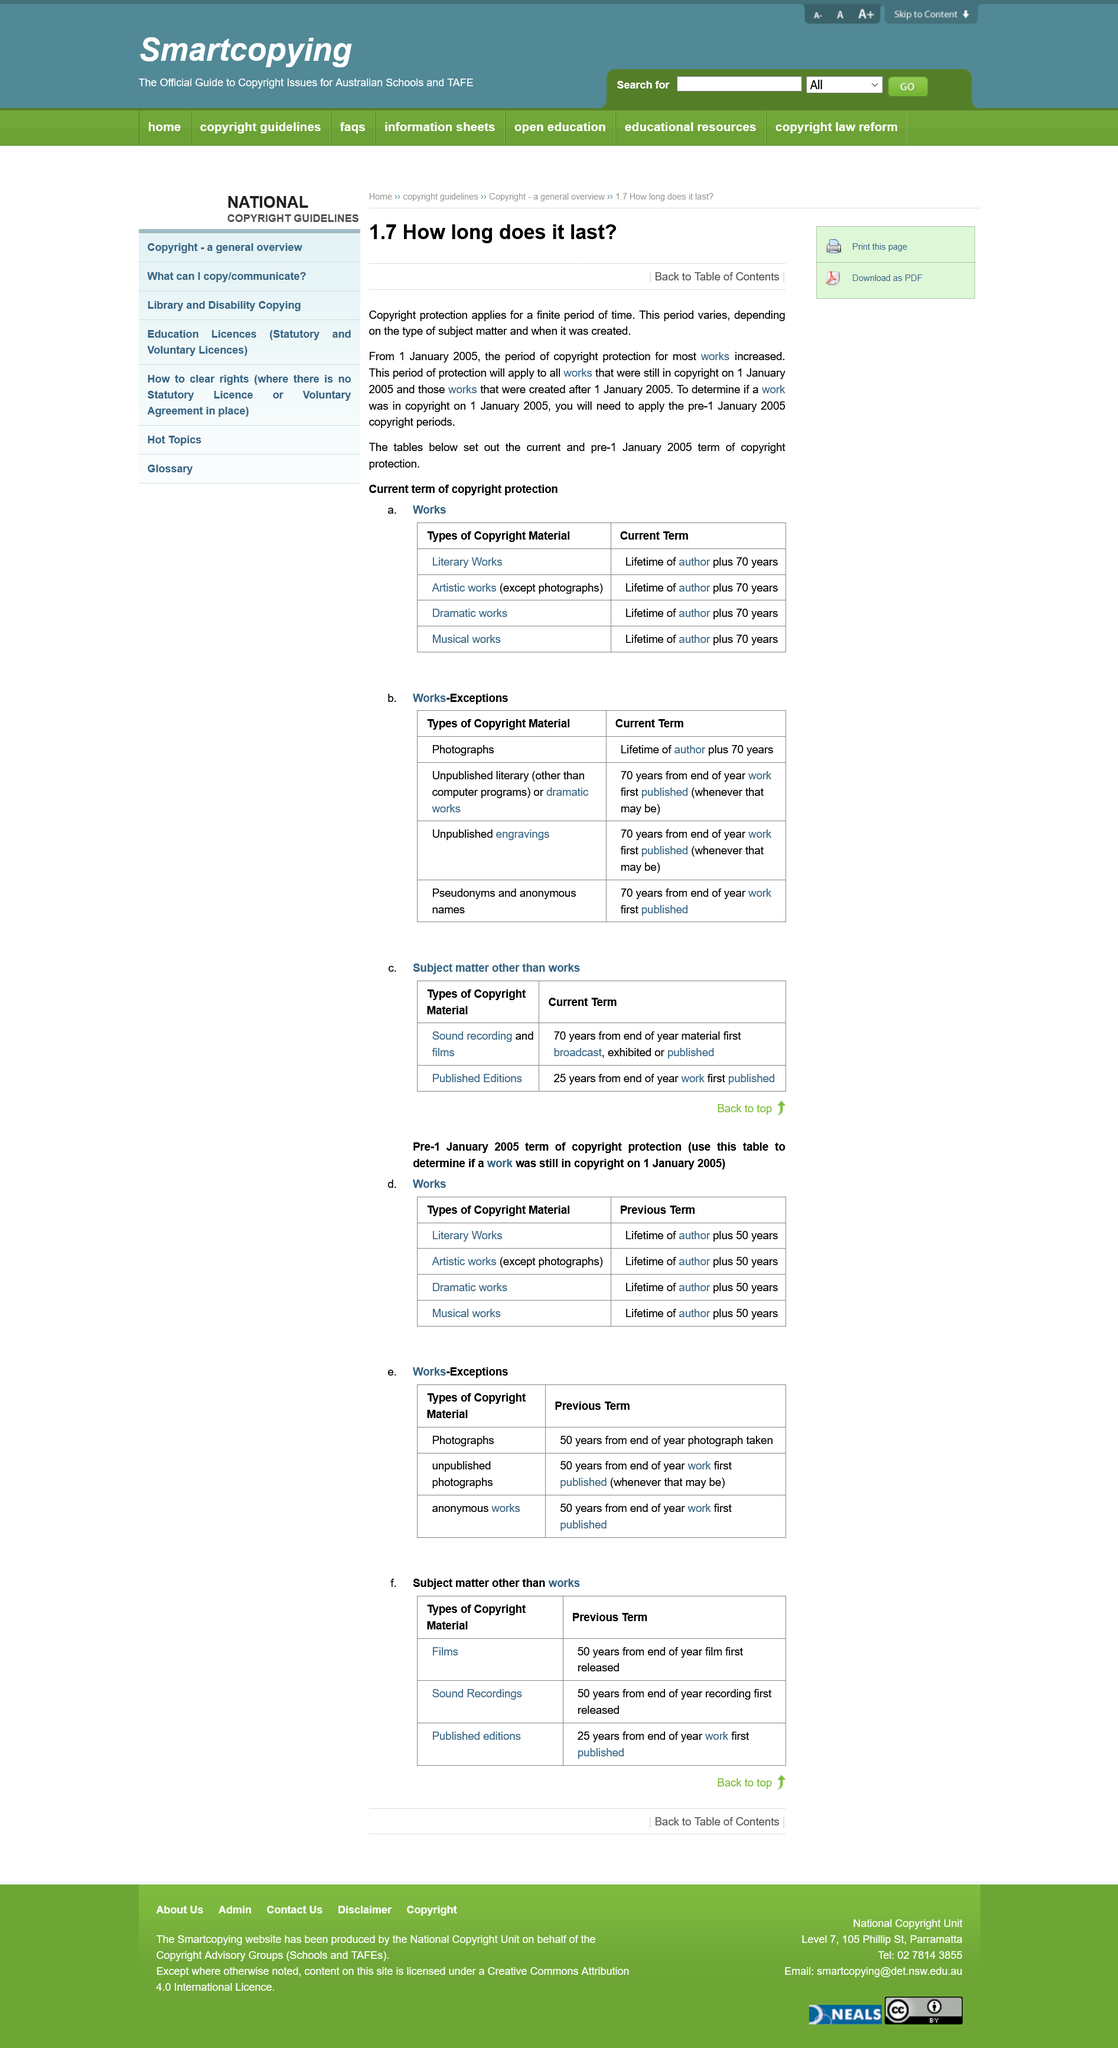Highlight a few significant elements in this photo. To determine if a work was in copyright protection on 1 January 2005, it is necessary to apply the pre-1 January 2005 copyright periods. Yes, the period of copyright protection can vary. The period of copyright protection for most works increased on 1 January 2005. 